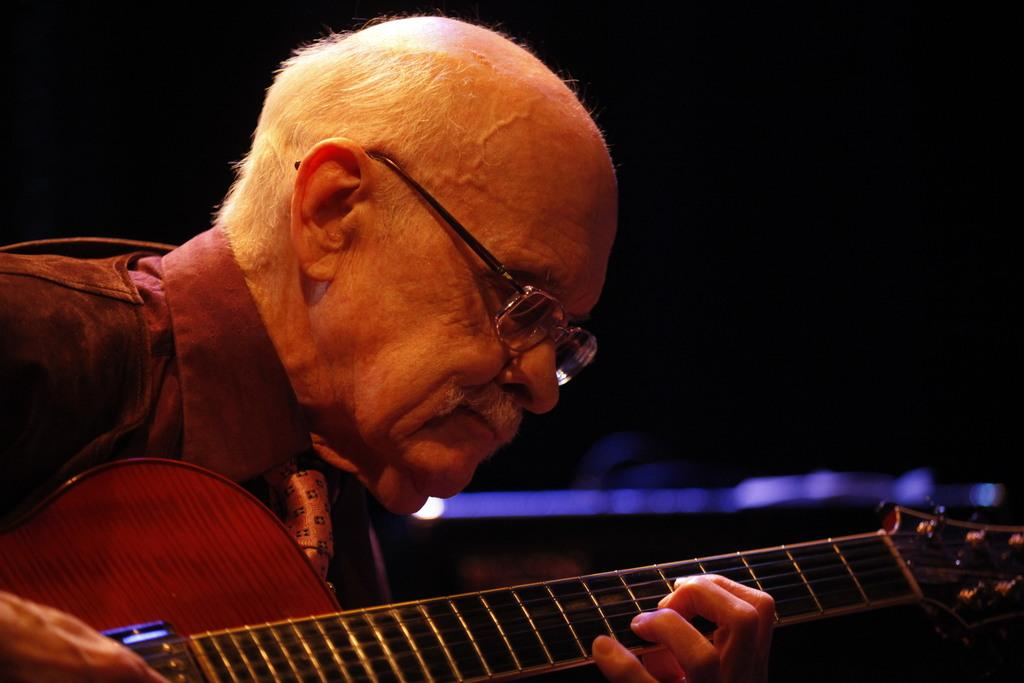What is the main subject of the image? The main subject of the image is a man. Can you describe the man's appearance in the image? The man is wearing specs in the image. What is the man holding in the image? The man is holding a guitar in the image. What is the color of the background in the image? The background of the image is dark. What type of bead is the man wearing around his neck in the image? There is no bead visible around the man's neck in the image. What type of button is the man wearing on his shirt in the image? There is no button visible on the man's shirt in the image. 